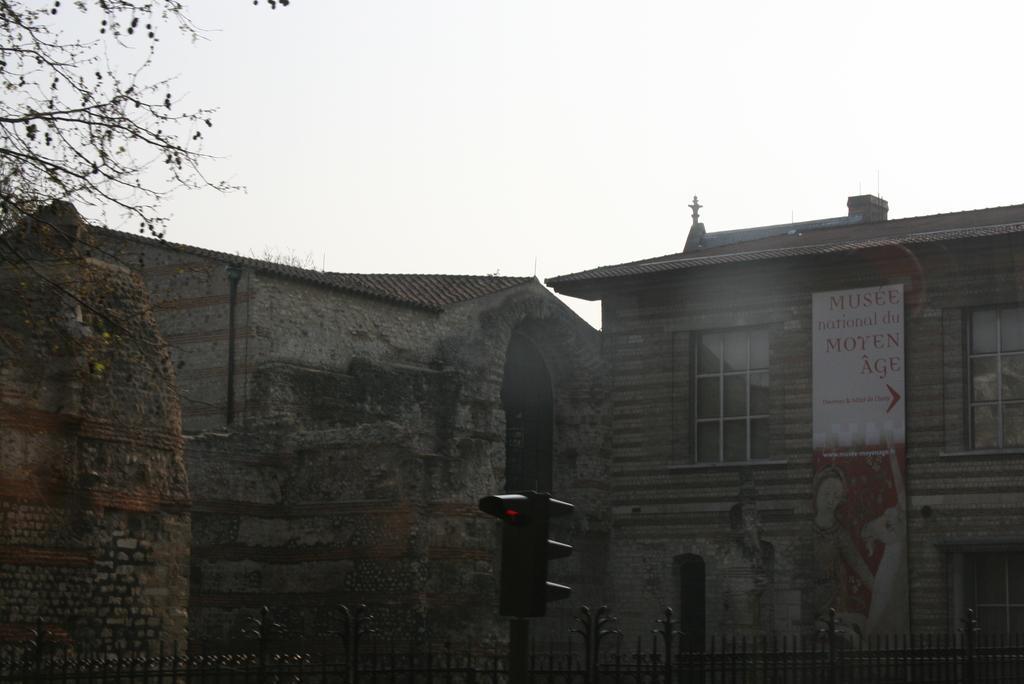Could you give a brief overview of what you see in this image? In this image there is a traffic signal light in the middle. In the background there are buildings. On the right side there is a hoarding attached to the building. At the bottom there is fence. On the left side top there is a tree. 